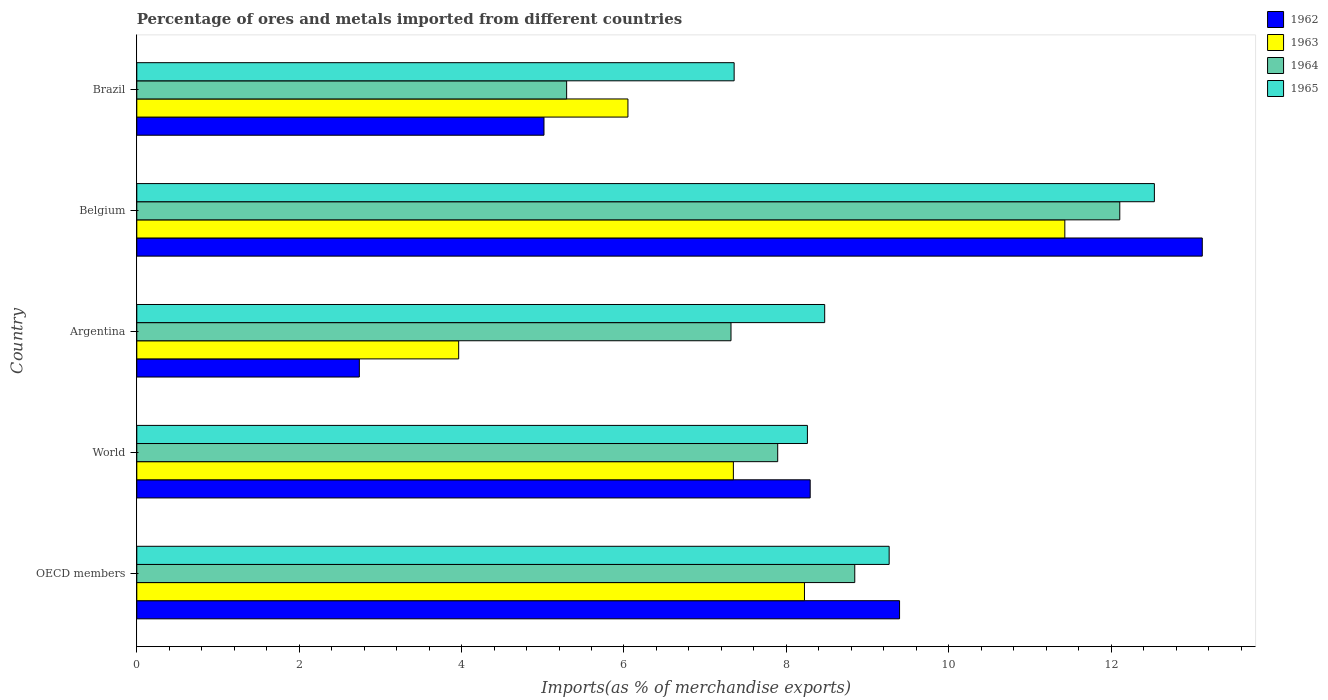How many groups of bars are there?
Keep it short and to the point. 5. Are the number of bars per tick equal to the number of legend labels?
Give a very brief answer. Yes. Are the number of bars on each tick of the Y-axis equal?
Your response must be concise. Yes. How many bars are there on the 2nd tick from the bottom?
Your response must be concise. 4. What is the label of the 1st group of bars from the top?
Provide a succinct answer. Brazil. What is the percentage of imports to different countries in 1962 in OECD members?
Make the answer very short. 9.39. Across all countries, what is the maximum percentage of imports to different countries in 1964?
Make the answer very short. 12.11. Across all countries, what is the minimum percentage of imports to different countries in 1965?
Make the answer very short. 7.36. What is the total percentage of imports to different countries in 1962 in the graph?
Your answer should be very brief. 38.56. What is the difference between the percentage of imports to different countries in 1962 in Argentina and that in World?
Provide a short and direct response. -5.55. What is the difference between the percentage of imports to different countries in 1965 in Brazil and the percentage of imports to different countries in 1964 in World?
Keep it short and to the point. -0.54. What is the average percentage of imports to different countries in 1965 per country?
Offer a very short reply. 9.18. What is the difference between the percentage of imports to different countries in 1963 and percentage of imports to different countries in 1965 in Belgium?
Provide a succinct answer. -1.1. In how many countries, is the percentage of imports to different countries in 1965 greater than 8.8 %?
Ensure brevity in your answer.  2. What is the ratio of the percentage of imports to different countries in 1962 in Brazil to that in OECD members?
Make the answer very short. 0.53. What is the difference between the highest and the second highest percentage of imports to different countries in 1965?
Offer a very short reply. 3.27. What is the difference between the highest and the lowest percentage of imports to different countries in 1965?
Your response must be concise. 5.18. In how many countries, is the percentage of imports to different countries in 1962 greater than the average percentage of imports to different countries in 1962 taken over all countries?
Offer a very short reply. 3. Is it the case that in every country, the sum of the percentage of imports to different countries in 1962 and percentage of imports to different countries in 1965 is greater than the sum of percentage of imports to different countries in 1964 and percentage of imports to different countries in 1963?
Provide a succinct answer. No. What does the 1st bar from the top in Brazil represents?
Make the answer very short. 1965. Is it the case that in every country, the sum of the percentage of imports to different countries in 1963 and percentage of imports to different countries in 1965 is greater than the percentage of imports to different countries in 1964?
Make the answer very short. Yes. How many bars are there?
Your answer should be compact. 20. Are all the bars in the graph horizontal?
Offer a terse response. Yes. How many countries are there in the graph?
Your answer should be very brief. 5. What is the difference between two consecutive major ticks on the X-axis?
Offer a terse response. 2. What is the title of the graph?
Provide a succinct answer. Percentage of ores and metals imported from different countries. Does "2015" appear as one of the legend labels in the graph?
Ensure brevity in your answer.  No. What is the label or title of the X-axis?
Your answer should be compact. Imports(as % of merchandise exports). What is the Imports(as % of merchandise exports) of 1962 in OECD members?
Keep it short and to the point. 9.39. What is the Imports(as % of merchandise exports) of 1963 in OECD members?
Ensure brevity in your answer.  8.22. What is the Imports(as % of merchandise exports) of 1964 in OECD members?
Your answer should be compact. 8.84. What is the Imports(as % of merchandise exports) of 1965 in OECD members?
Provide a succinct answer. 9.27. What is the Imports(as % of merchandise exports) of 1962 in World?
Your answer should be compact. 8.29. What is the Imports(as % of merchandise exports) of 1963 in World?
Ensure brevity in your answer.  7.35. What is the Imports(as % of merchandise exports) in 1964 in World?
Your answer should be very brief. 7.89. What is the Imports(as % of merchandise exports) in 1965 in World?
Your answer should be very brief. 8.26. What is the Imports(as % of merchandise exports) in 1962 in Argentina?
Give a very brief answer. 2.74. What is the Imports(as % of merchandise exports) in 1963 in Argentina?
Provide a succinct answer. 3.96. What is the Imports(as % of merchandise exports) in 1964 in Argentina?
Your answer should be very brief. 7.32. What is the Imports(as % of merchandise exports) in 1965 in Argentina?
Offer a very short reply. 8.47. What is the Imports(as % of merchandise exports) of 1962 in Belgium?
Your response must be concise. 13.12. What is the Imports(as % of merchandise exports) of 1963 in Belgium?
Your response must be concise. 11.43. What is the Imports(as % of merchandise exports) in 1964 in Belgium?
Keep it short and to the point. 12.11. What is the Imports(as % of merchandise exports) of 1965 in Belgium?
Give a very brief answer. 12.53. What is the Imports(as % of merchandise exports) of 1962 in Brazil?
Your answer should be very brief. 5.01. What is the Imports(as % of merchandise exports) in 1963 in Brazil?
Your response must be concise. 6.05. What is the Imports(as % of merchandise exports) of 1964 in Brazil?
Give a very brief answer. 5.29. What is the Imports(as % of merchandise exports) of 1965 in Brazil?
Provide a short and direct response. 7.36. Across all countries, what is the maximum Imports(as % of merchandise exports) in 1962?
Provide a short and direct response. 13.12. Across all countries, what is the maximum Imports(as % of merchandise exports) of 1963?
Make the answer very short. 11.43. Across all countries, what is the maximum Imports(as % of merchandise exports) in 1964?
Provide a short and direct response. 12.11. Across all countries, what is the maximum Imports(as % of merchandise exports) of 1965?
Ensure brevity in your answer.  12.53. Across all countries, what is the minimum Imports(as % of merchandise exports) of 1962?
Offer a terse response. 2.74. Across all countries, what is the minimum Imports(as % of merchandise exports) in 1963?
Provide a short and direct response. 3.96. Across all countries, what is the minimum Imports(as % of merchandise exports) in 1964?
Make the answer very short. 5.29. Across all countries, what is the minimum Imports(as % of merchandise exports) of 1965?
Your response must be concise. 7.36. What is the total Imports(as % of merchandise exports) in 1962 in the graph?
Give a very brief answer. 38.56. What is the total Imports(as % of merchandise exports) of 1963 in the graph?
Your answer should be very brief. 37.01. What is the total Imports(as % of merchandise exports) of 1964 in the graph?
Your response must be concise. 41.45. What is the total Imports(as % of merchandise exports) of 1965 in the graph?
Provide a succinct answer. 45.89. What is the difference between the Imports(as % of merchandise exports) of 1962 in OECD members and that in World?
Provide a succinct answer. 1.1. What is the difference between the Imports(as % of merchandise exports) of 1963 in OECD members and that in World?
Give a very brief answer. 0.88. What is the difference between the Imports(as % of merchandise exports) of 1964 in OECD members and that in World?
Provide a succinct answer. 0.95. What is the difference between the Imports(as % of merchandise exports) of 1965 in OECD members and that in World?
Your response must be concise. 1.01. What is the difference between the Imports(as % of merchandise exports) of 1962 in OECD members and that in Argentina?
Your answer should be compact. 6.65. What is the difference between the Imports(as % of merchandise exports) of 1963 in OECD members and that in Argentina?
Give a very brief answer. 4.26. What is the difference between the Imports(as % of merchandise exports) of 1964 in OECD members and that in Argentina?
Offer a very short reply. 1.52. What is the difference between the Imports(as % of merchandise exports) in 1965 in OECD members and that in Argentina?
Provide a short and direct response. 0.79. What is the difference between the Imports(as % of merchandise exports) of 1962 in OECD members and that in Belgium?
Keep it short and to the point. -3.73. What is the difference between the Imports(as % of merchandise exports) in 1963 in OECD members and that in Belgium?
Provide a short and direct response. -3.21. What is the difference between the Imports(as % of merchandise exports) of 1964 in OECD members and that in Belgium?
Offer a very short reply. -3.26. What is the difference between the Imports(as % of merchandise exports) in 1965 in OECD members and that in Belgium?
Make the answer very short. -3.27. What is the difference between the Imports(as % of merchandise exports) of 1962 in OECD members and that in Brazil?
Give a very brief answer. 4.38. What is the difference between the Imports(as % of merchandise exports) in 1963 in OECD members and that in Brazil?
Your answer should be compact. 2.17. What is the difference between the Imports(as % of merchandise exports) in 1964 in OECD members and that in Brazil?
Your answer should be compact. 3.55. What is the difference between the Imports(as % of merchandise exports) of 1965 in OECD members and that in Brazil?
Give a very brief answer. 1.91. What is the difference between the Imports(as % of merchandise exports) of 1962 in World and that in Argentina?
Give a very brief answer. 5.55. What is the difference between the Imports(as % of merchandise exports) of 1963 in World and that in Argentina?
Offer a terse response. 3.38. What is the difference between the Imports(as % of merchandise exports) of 1964 in World and that in Argentina?
Provide a short and direct response. 0.58. What is the difference between the Imports(as % of merchandise exports) in 1965 in World and that in Argentina?
Make the answer very short. -0.21. What is the difference between the Imports(as % of merchandise exports) of 1962 in World and that in Belgium?
Offer a very short reply. -4.83. What is the difference between the Imports(as % of merchandise exports) of 1963 in World and that in Belgium?
Ensure brevity in your answer.  -4.08. What is the difference between the Imports(as % of merchandise exports) of 1964 in World and that in Belgium?
Your response must be concise. -4.21. What is the difference between the Imports(as % of merchandise exports) of 1965 in World and that in Belgium?
Provide a succinct answer. -4.27. What is the difference between the Imports(as % of merchandise exports) of 1962 in World and that in Brazil?
Your answer should be compact. 3.28. What is the difference between the Imports(as % of merchandise exports) in 1963 in World and that in Brazil?
Offer a very short reply. 1.3. What is the difference between the Imports(as % of merchandise exports) in 1964 in World and that in Brazil?
Provide a short and direct response. 2.6. What is the difference between the Imports(as % of merchandise exports) in 1965 in World and that in Brazil?
Your answer should be compact. 0.9. What is the difference between the Imports(as % of merchandise exports) of 1962 in Argentina and that in Belgium?
Give a very brief answer. -10.38. What is the difference between the Imports(as % of merchandise exports) in 1963 in Argentina and that in Belgium?
Your answer should be compact. -7.46. What is the difference between the Imports(as % of merchandise exports) of 1964 in Argentina and that in Belgium?
Give a very brief answer. -4.79. What is the difference between the Imports(as % of merchandise exports) in 1965 in Argentina and that in Belgium?
Ensure brevity in your answer.  -4.06. What is the difference between the Imports(as % of merchandise exports) in 1962 in Argentina and that in Brazil?
Your answer should be very brief. -2.27. What is the difference between the Imports(as % of merchandise exports) of 1963 in Argentina and that in Brazil?
Offer a very short reply. -2.08. What is the difference between the Imports(as % of merchandise exports) of 1964 in Argentina and that in Brazil?
Your answer should be very brief. 2.02. What is the difference between the Imports(as % of merchandise exports) of 1965 in Argentina and that in Brazil?
Your answer should be very brief. 1.12. What is the difference between the Imports(as % of merchandise exports) in 1962 in Belgium and that in Brazil?
Give a very brief answer. 8.11. What is the difference between the Imports(as % of merchandise exports) of 1963 in Belgium and that in Brazil?
Provide a succinct answer. 5.38. What is the difference between the Imports(as % of merchandise exports) in 1964 in Belgium and that in Brazil?
Offer a terse response. 6.81. What is the difference between the Imports(as % of merchandise exports) in 1965 in Belgium and that in Brazil?
Your answer should be very brief. 5.18. What is the difference between the Imports(as % of merchandise exports) in 1962 in OECD members and the Imports(as % of merchandise exports) in 1963 in World?
Ensure brevity in your answer.  2.05. What is the difference between the Imports(as % of merchandise exports) in 1962 in OECD members and the Imports(as % of merchandise exports) in 1964 in World?
Your response must be concise. 1.5. What is the difference between the Imports(as % of merchandise exports) of 1962 in OECD members and the Imports(as % of merchandise exports) of 1965 in World?
Your answer should be compact. 1.13. What is the difference between the Imports(as % of merchandise exports) in 1963 in OECD members and the Imports(as % of merchandise exports) in 1964 in World?
Give a very brief answer. 0.33. What is the difference between the Imports(as % of merchandise exports) in 1963 in OECD members and the Imports(as % of merchandise exports) in 1965 in World?
Keep it short and to the point. -0.04. What is the difference between the Imports(as % of merchandise exports) of 1964 in OECD members and the Imports(as % of merchandise exports) of 1965 in World?
Ensure brevity in your answer.  0.58. What is the difference between the Imports(as % of merchandise exports) in 1962 in OECD members and the Imports(as % of merchandise exports) in 1963 in Argentina?
Provide a short and direct response. 5.43. What is the difference between the Imports(as % of merchandise exports) in 1962 in OECD members and the Imports(as % of merchandise exports) in 1964 in Argentina?
Your answer should be very brief. 2.08. What is the difference between the Imports(as % of merchandise exports) in 1962 in OECD members and the Imports(as % of merchandise exports) in 1965 in Argentina?
Provide a succinct answer. 0.92. What is the difference between the Imports(as % of merchandise exports) of 1963 in OECD members and the Imports(as % of merchandise exports) of 1964 in Argentina?
Your answer should be compact. 0.9. What is the difference between the Imports(as % of merchandise exports) in 1963 in OECD members and the Imports(as % of merchandise exports) in 1965 in Argentina?
Provide a short and direct response. -0.25. What is the difference between the Imports(as % of merchandise exports) in 1964 in OECD members and the Imports(as % of merchandise exports) in 1965 in Argentina?
Give a very brief answer. 0.37. What is the difference between the Imports(as % of merchandise exports) in 1962 in OECD members and the Imports(as % of merchandise exports) in 1963 in Belgium?
Your answer should be very brief. -2.04. What is the difference between the Imports(as % of merchandise exports) of 1962 in OECD members and the Imports(as % of merchandise exports) of 1964 in Belgium?
Make the answer very short. -2.71. What is the difference between the Imports(as % of merchandise exports) of 1962 in OECD members and the Imports(as % of merchandise exports) of 1965 in Belgium?
Offer a terse response. -3.14. What is the difference between the Imports(as % of merchandise exports) in 1963 in OECD members and the Imports(as % of merchandise exports) in 1964 in Belgium?
Provide a short and direct response. -3.88. What is the difference between the Imports(as % of merchandise exports) of 1963 in OECD members and the Imports(as % of merchandise exports) of 1965 in Belgium?
Provide a short and direct response. -4.31. What is the difference between the Imports(as % of merchandise exports) in 1964 in OECD members and the Imports(as % of merchandise exports) in 1965 in Belgium?
Your answer should be very brief. -3.69. What is the difference between the Imports(as % of merchandise exports) of 1962 in OECD members and the Imports(as % of merchandise exports) of 1963 in Brazil?
Provide a succinct answer. 3.35. What is the difference between the Imports(as % of merchandise exports) of 1962 in OECD members and the Imports(as % of merchandise exports) of 1964 in Brazil?
Make the answer very short. 4.1. What is the difference between the Imports(as % of merchandise exports) of 1962 in OECD members and the Imports(as % of merchandise exports) of 1965 in Brazil?
Offer a terse response. 2.04. What is the difference between the Imports(as % of merchandise exports) of 1963 in OECD members and the Imports(as % of merchandise exports) of 1964 in Brazil?
Ensure brevity in your answer.  2.93. What is the difference between the Imports(as % of merchandise exports) in 1963 in OECD members and the Imports(as % of merchandise exports) in 1965 in Brazil?
Your response must be concise. 0.87. What is the difference between the Imports(as % of merchandise exports) of 1964 in OECD members and the Imports(as % of merchandise exports) of 1965 in Brazil?
Your answer should be very brief. 1.49. What is the difference between the Imports(as % of merchandise exports) in 1962 in World and the Imports(as % of merchandise exports) in 1963 in Argentina?
Offer a very short reply. 4.33. What is the difference between the Imports(as % of merchandise exports) of 1962 in World and the Imports(as % of merchandise exports) of 1964 in Argentina?
Offer a very short reply. 0.98. What is the difference between the Imports(as % of merchandise exports) in 1962 in World and the Imports(as % of merchandise exports) in 1965 in Argentina?
Ensure brevity in your answer.  -0.18. What is the difference between the Imports(as % of merchandise exports) of 1963 in World and the Imports(as % of merchandise exports) of 1964 in Argentina?
Ensure brevity in your answer.  0.03. What is the difference between the Imports(as % of merchandise exports) of 1963 in World and the Imports(as % of merchandise exports) of 1965 in Argentina?
Keep it short and to the point. -1.12. What is the difference between the Imports(as % of merchandise exports) in 1964 in World and the Imports(as % of merchandise exports) in 1965 in Argentina?
Make the answer very short. -0.58. What is the difference between the Imports(as % of merchandise exports) in 1962 in World and the Imports(as % of merchandise exports) in 1963 in Belgium?
Offer a very short reply. -3.14. What is the difference between the Imports(as % of merchandise exports) in 1962 in World and the Imports(as % of merchandise exports) in 1964 in Belgium?
Your answer should be very brief. -3.81. What is the difference between the Imports(as % of merchandise exports) in 1962 in World and the Imports(as % of merchandise exports) in 1965 in Belgium?
Provide a succinct answer. -4.24. What is the difference between the Imports(as % of merchandise exports) of 1963 in World and the Imports(as % of merchandise exports) of 1964 in Belgium?
Give a very brief answer. -4.76. What is the difference between the Imports(as % of merchandise exports) of 1963 in World and the Imports(as % of merchandise exports) of 1965 in Belgium?
Give a very brief answer. -5.18. What is the difference between the Imports(as % of merchandise exports) in 1964 in World and the Imports(as % of merchandise exports) in 1965 in Belgium?
Make the answer very short. -4.64. What is the difference between the Imports(as % of merchandise exports) in 1962 in World and the Imports(as % of merchandise exports) in 1963 in Brazil?
Offer a terse response. 2.24. What is the difference between the Imports(as % of merchandise exports) in 1962 in World and the Imports(as % of merchandise exports) in 1964 in Brazil?
Make the answer very short. 3. What is the difference between the Imports(as % of merchandise exports) in 1962 in World and the Imports(as % of merchandise exports) in 1965 in Brazil?
Make the answer very short. 0.94. What is the difference between the Imports(as % of merchandise exports) of 1963 in World and the Imports(as % of merchandise exports) of 1964 in Brazil?
Provide a succinct answer. 2.05. What is the difference between the Imports(as % of merchandise exports) in 1963 in World and the Imports(as % of merchandise exports) in 1965 in Brazil?
Make the answer very short. -0.01. What is the difference between the Imports(as % of merchandise exports) of 1964 in World and the Imports(as % of merchandise exports) of 1965 in Brazil?
Your answer should be compact. 0.54. What is the difference between the Imports(as % of merchandise exports) of 1962 in Argentina and the Imports(as % of merchandise exports) of 1963 in Belgium?
Ensure brevity in your answer.  -8.69. What is the difference between the Imports(as % of merchandise exports) in 1962 in Argentina and the Imports(as % of merchandise exports) in 1964 in Belgium?
Your answer should be very brief. -9.37. What is the difference between the Imports(as % of merchandise exports) of 1962 in Argentina and the Imports(as % of merchandise exports) of 1965 in Belgium?
Provide a short and direct response. -9.79. What is the difference between the Imports(as % of merchandise exports) in 1963 in Argentina and the Imports(as % of merchandise exports) in 1964 in Belgium?
Provide a succinct answer. -8.14. What is the difference between the Imports(as % of merchandise exports) in 1963 in Argentina and the Imports(as % of merchandise exports) in 1965 in Belgium?
Give a very brief answer. -8.57. What is the difference between the Imports(as % of merchandise exports) of 1964 in Argentina and the Imports(as % of merchandise exports) of 1965 in Belgium?
Your answer should be compact. -5.21. What is the difference between the Imports(as % of merchandise exports) in 1962 in Argentina and the Imports(as % of merchandise exports) in 1963 in Brazil?
Provide a succinct answer. -3.31. What is the difference between the Imports(as % of merchandise exports) in 1962 in Argentina and the Imports(as % of merchandise exports) in 1964 in Brazil?
Keep it short and to the point. -2.55. What is the difference between the Imports(as % of merchandise exports) in 1962 in Argentina and the Imports(as % of merchandise exports) in 1965 in Brazil?
Your answer should be compact. -4.62. What is the difference between the Imports(as % of merchandise exports) in 1963 in Argentina and the Imports(as % of merchandise exports) in 1964 in Brazil?
Give a very brief answer. -1.33. What is the difference between the Imports(as % of merchandise exports) of 1963 in Argentina and the Imports(as % of merchandise exports) of 1965 in Brazil?
Your answer should be compact. -3.39. What is the difference between the Imports(as % of merchandise exports) of 1964 in Argentina and the Imports(as % of merchandise exports) of 1965 in Brazil?
Your answer should be very brief. -0.04. What is the difference between the Imports(as % of merchandise exports) in 1962 in Belgium and the Imports(as % of merchandise exports) in 1963 in Brazil?
Provide a succinct answer. 7.07. What is the difference between the Imports(as % of merchandise exports) in 1962 in Belgium and the Imports(as % of merchandise exports) in 1964 in Brazil?
Your answer should be very brief. 7.83. What is the difference between the Imports(as % of merchandise exports) in 1962 in Belgium and the Imports(as % of merchandise exports) in 1965 in Brazil?
Your answer should be compact. 5.77. What is the difference between the Imports(as % of merchandise exports) in 1963 in Belgium and the Imports(as % of merchandise exports) in 1964 in Brazil?
Give a very brief answer. 6.14. What is the difference between the Imports(as % of merchandise exports) in 1963 in Belgium and the Imports(as % of merchandise exports) in 1965 in Brazil?
Make the answer very short. 4.07. What is the difference between the Imports(as % of merchandise exports) of 1964 in Belgium and the Imports(as % of merchandise exports) of 1965 in Brazil?
Your response must be concise. 4.75. What is the average Imports(as % of merchandise exports) of 1962 per country?
Your answer should be compact. 7.71. What is the average Imports(as % of merchandise exports) in 1963 per country?
Offer a very short reply. 7.4. What is the average Imports(as % of merchandise exports) of 1964 per country?
Ensure brevity in your answer.  8.29. What is the average Imports(as % of merchandise exports) in 1965 per country?
Your response must be concise. 9.18. What is the difference between the Imports(as % of merchandise exports) of 1962 and Imports(as % of merchandise exports) of 1963 in OECD members?
Give a very brief answer. 1.17. What is the difference between the Imports(as % of merchandise exports) in 1962 and Imports(as % of merchandise exports) in 1964 in OECD members?
Your response must be concise. 0.55. What is the difference between the Imports(as % of merchandise exports) of 1962 and Imports(as % of merchandise exports) of 1965 in OECD members?
Keep it short and to the point. 0.13. What is the difference between the Imports(as % of merchandise exports) of 1963 and Imports(as % of merchandise exports) of 1964 in OECD members?
Provide a short and direct response. -0.62. What is the difference between the Imports(as % of merchandise exports) of 1963 and Imports(as % of merchandise exports) of 1965 in OECD members?
Keep it short and to the point. -1.04. What is the difference between the Imports(as % of merchandise exports) in 1964 and Imports(as % of merchandise exports) in 1965 in OECD members?
Keep it short and to the point. -0.42. What is the difference between the Imports(as % of merchandise exports) in 1962 and Imports(as % of merchandise exports) in 1963 in World?
Your response must be concise. 0.95. What is the difference between the Imports(as % of merchandise exports) of 1962 and Imports(as % of merchandise exports) of 1964 in World?
Offer a very short reply. 0.4. What is the difference between the Imports(as % of merchandise exports) in 1962 and Imports(as % of merchandise exports) in 1965 in World?
Provide a short and direct response. 0.03. What is the difference between the Imports(as % of merchandise exports) of 1963 and Imports(as % of merchandise exports) of 1964 in World?
Offer a very short reply. -0.55. What is the difference between the Imports(as % of merchandise exports) of 1963 and Imports(as % of merchandise exports) of 1965 in World?
Give a very brief answer. -0.91. What is the difference between the Imports(as % of merchandise exports) in 1964 and Imports(as % of merchandise exports) in 1965 in World?
Make the answer very short. -0.37. What is the difference between the Imports(as % of merchandise exports) in 1962 and Imports(as % of merchandise exports) in 1963 in Argentina?
Make the answer very short. -1.22. What is the difference between the Imports(as % of merchandise exports) of 1962 and Imports(as % of merchandise exports) of 1964 in Argentina?
Give a very brief answer. -4.58. What is the difference between the Imports(as % of merchandise exports) in 1962 and Imports(as % of merchandise exports) in 1965 in Argentina?
Make the answer very short. -5.73. What is the difference between the Imports(as % of merchandise exports) of 1963 and Imports(as % of merchandise exports) of 1964 in Argentina?
Offer a very short reply. -3.35. What is the difference between the Imports(as % of merchandise exports) in 1963 and Imports(as % of merchandise exports) in 1965 in Argentina?
Give a very brief answer. -4.51. What is the difference between the Imports(as % of merchandise exports) in 1964 and Imports(as % of merchandise exports) in 1965 in Argentina?
Your answer should be compact. -1.15. What is the difference between the Imports(as % of merchandise exports) of 1962 and Imports(as % of merchandise exports) of 1963 in Belgium?
Keep it short and to the point. 1.69. What is the difference between the Imports(as % of merchandise exports) in 1962 and Imports(as % of merchandise exports) in 1964 in Belgium?
Give a very brief answer. 1.02. What is the difference between the Imports(as % of merchandise exports) of 1962 and Imports(as % of merchandise exports) of 1965 in Belgium?
Give a very brief answer. 0.59. What is the difference between the Imports(as % of merchandise exports) of 1963 and Imports(as % of merchandise exports) of 1964 in Belgium?
Keep it short and to the point. -0.68. What is the difference between the Imports(as % of merchandise exports) in 1963 and Imports(as % of merchandise exports) in 1965 in Belgium?
Give a very brief answer. -1.1. What is the difference between the Imports(as % of merchandise exports) in 1964 and Imports(as % of merchandise exports) in 1965 in Belgium?
Offer a very short reply. -0.43. What is the difference between the Imports(as % of merchandise exports) of 1962 and Imports(as % of merchandise exports) of 1963 in Brazil?
Offer a very short reply. -1.03. What is the difference between the Imports(as % of merchandise exports) in 1962 and Imports(as % of merchandise exports) in 1964 in Brazil?
Ensure brevity in your answer.  -0.28. What is the difference between the Imports(as % of merchandise exports) in 1962 and Imports(as % of merchandise exports) in 1965 in Brazil?
Make the answer very short. -2.34. What is the difference between the Imports(as % of merchandise exports) of 1963 and Imports(as % of merchandise exports) of 1964 in Brazil?
Provide a short and direct response. 0.75. What is the difference between the Imports(as % of merchandise exports) of 1963 and Imports(as % of merchandise exports) of 1965 in Brazil?
Ensure brevity in your answer.  -1.31. What is the difference between the Imports(as % of merchandise exports) of 1964 and Imports(as % of merchandise exports) of 1965 in Brazil?
Offer a very short reply. -2.06. What is the ratio of the Imports(as % of merchandise exports) of 1962 in OECD members to that in World?
Make the answer very short. 1.13. What is the ratio of the Imports(as % of merchandise exports) in 1963 in OECD members to that in World?
Keep it short and to the point. 1.12. What is the ratio of the Imports(as % of merchandise exports) in 1964 in OECD members to that in World?
Your response must be concise. 1.12. What is the ratio of the Imports(as % of merchandise exports) in 1965 in OECD members to that in World?
Provide a succinct answer. 1.12. What is the ratio of the Imports(as % of merchandise exports) in 1962 in OECD members to that in Argentina?
Your answer should be very brief. 3.43. What is the ratio of the Imports(as % of merchandise exports) of 1963 in OECD members to that in Argentina?
Your answer should be compact. 2.07. What is the ratio of the Imports(as % of merchandise exports) of 1964 in OECD members to that in Argentina?
Offer a very short reply. 1.21. What is the ratio of the Imports(as % of merchandise exports) in 1965 in OECD members to that in Argentina?
Your answer should be very brief. 1.09. What is the ratio of the Imports(as % of merchandise exports) of 1962 in OECD members to that in Belgium?
Keep it short and to the point. 0.72. What is the ratio of the Imports(as % of merchandise exports) of 1963 in OECD members to that in Belgium?
Give a very brief answer. 0.72. What is the ratio of the Imports(as % of merchandise exports) of 1964 in OECD members to that in Belgium?
Provide a succinct answer. 0.73. What is the ratio of the Imports(as % of merchandise exports) in 1965 in OECD members to that in Belgium?
Provide a short and direct response. 0.74. What is the ratio of the Imports(as % of merchandise exports) in 1962 in OECD members to that in Brazil?
Give a very brief answer. 1.87. What is the ratio of the Imports(as % of merchandise exports) in 1963 in OECD members to that in Brazil?
Provide a succinct answer. 1.36. What is the ratio of the Imports(as % of merchandise exports) in 1964 in OECD members to that in Brazil?
Keep it short and to the point. 1.67. What is the ratio of the Imports(as % of merchandise exports) in 1965 in OECD members to that in Brazil?
Your answer should be very brief. 1.26. What is the ratio of the Imports(as % of merchandise exports) in 1962 in World to that in Argentina?
Offer a terse response. 3.03. What is the ratio of the Imports(as % of merchandise exports) of 1963 in World to that in Argentina?
Ensure brevity in your answer.  1.85. What is the ratio of the Imports(as % of merchandise exports) of 1964 in World to that in Argentina?
Give a very brief answer. 1.08. What is the ratio of the Imports(as % of merchandise exports) of 1965 in World to that in Argentina?
Offer a very short reply. 0.97. What is the ratio of the Imports(as % of merchandise exports) in 1962 in World to that in Belgium?
Your response must be concise. 0.63. What is the ratio of the Imports(as % of merchandise exports) of 1963 in World to that in Belgium?
Provide a short and direct response. 0.64. What is the ratio of the Imports(as % of merchandise exports) of 1964 in World to that in Belgium?
Offer a terse response. 0.65. What is the ratio of the Imports(as % of merchandise exports) of 1965 in World to that in Belgium?
Offer a terse response. 0.66. What is the ratio of the Imports(as % of merchandise exports) of 1962 in World to that in Brazil?
Make the answer very short. 1.65. What is the ratio of the Imports(as % of merchandise exports) in 1963 in World to that in Brazil?
Provide a short and direct response. 1.21. What is the ratio of the Imports(as % of merchandise exports) of 1964 in World to that in Brazil?
Provide a succinct answer. 1.49. What is the ratio of the Imports(as % of merchandise exports) in 1965 in World to that in Brazil?
Your response must be concise. 1.12. What is the ratio of the Imports(as % of merchandise exports) in 1962 in Argentina to that in Belgium?
Provide a succinct answer. 0.21. What is the ratio of the Imports(as % of merchandise exports) of 1963 in Argentina to that in Belgium?
Your answer should be very brief. 0.35. What is the ratio of the Imports(as % of merchandise exports) of 1964 in Argentina to that in Belgium?
Provide a short and direct response. 0.6. What is the ratio of the Imports(as % of merchandise exports) in 1965 in Argentina to that in Belgium?
Your response must be concise. 0.68. What is the ratio of the Imports(as % of merchandise exports) of 1962 in Argentina to that in Brazil?
Offer a very short reply. 0.55. What is the ratio of the Imports(as % of merchandise exports) of 1963 in Argentina to that in Brazil?
Offer a terse response. 0.66. What is the ratio of the Imports(as % of merchandise exports) in 1964 in Argentina to that in Brazil?
Your response must be concise. 1.38. What is the ratio of the Imports(as % of merchandise exports) of 1965 in Argentina to that in Brazil?
Offer a terse response. 1.15. What is the ratio of the Imports(as % of merchandise exports) in 1962 in Belgium to that in Brazil?
Your answer should be very brief. 2.62. What is the ratio of the Imports(as % of merchandise exports) of 1963 in Belgium to that in Brazil?
Keep it short and to the point. 1.89. What is the ratio of the Imports(as % of merchandise exports) of 1964 in Belgium to that in Brazil?
Offer a terse response. 2.29. What is the ratio of the Imports(as % of merchandise exports) of 1965 in Belgium to that in Brazil?
Give a very brief answer. 1.7. What is the difference between the highest and the second highest Imports(as % of merchandise exports) in 1962?
Give a very brief answer. 3.73. What is the difference between the highest and the second highest Imports(as % of merchandise exports) in 1963?
Your response must be concise. 3.21. What is the difference between the highest and the second highest Imports(as % of merchandise exports) of 1964?
Give a very brief answer. 3.26. What is the difference between the highest and the second highest Imports(as % of merchandise exports) of 1965?
Make the answer very short. 3.27. What is the difference between the highest and the lowest Imports(as % of merchandise exports) of 1962?
Your answer should be very brief. 10.38. What is the difference between the highest and the lowest Imports(as % of merchandise exports) of 1963?
Provide a succinct answer. 7.46. What is the difference between the highest and the lowest Imports(as % of merchandise exports) of 1964?
Your answer should be compact. 6.81. What is the difference between the highest and the lowest Imports(as % of merchandise exports) of 1965?
Your answer should be very brief. 5.18. 